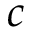Convert formula to latex. <formula><loc_0><loc_0><loc_500><loc_500>c</formula> 